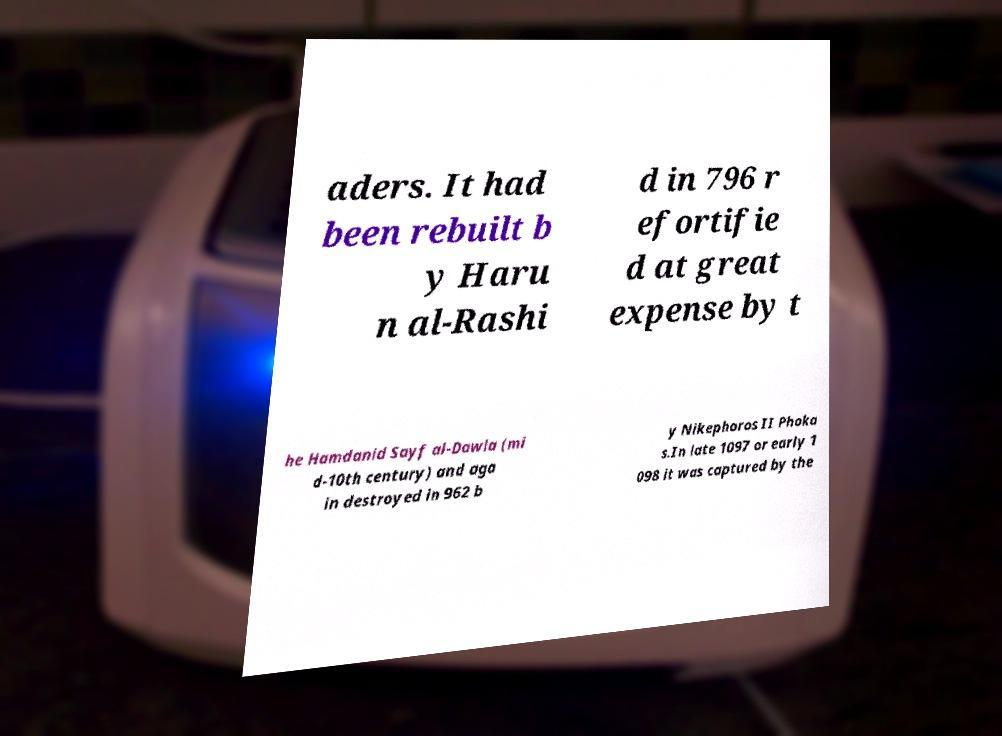There's text embedded in this image that I need extracted. Can you transcribe it verbatim? aders. It had been rebuilt b y Haru n al-Rashi d in 796 r efortifie d at great expense by t he Hamdanid Sayf al-Dawla (mi d-10th century) and aga in destroyed in 962 b y Nikephoros II Phoka s.In late 1097 or early 1 098 it was captured by the 